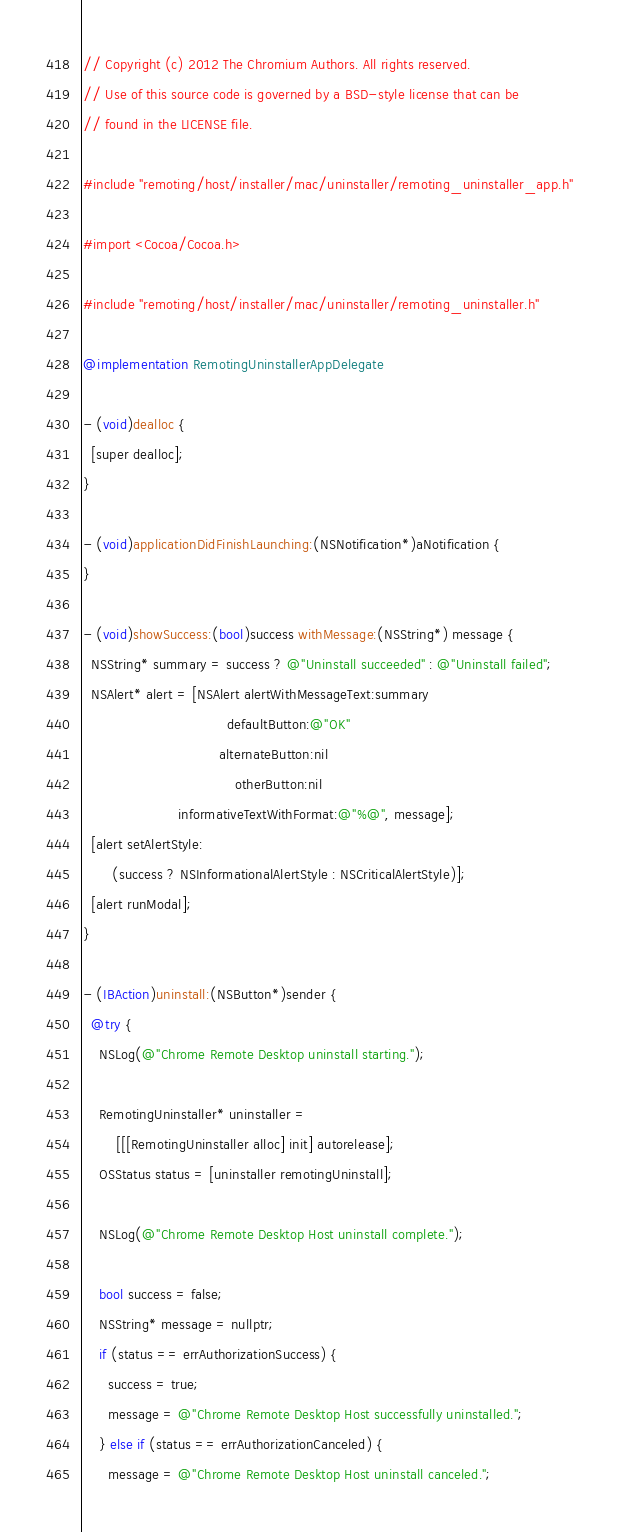<code> <loc_0><loc_0><loc_500><loc_500><_ObjectiveC_>// Copyright (c) 2012 The Chromium Authors. All rights reserved.
// Use of this source code is governed by a BSD-style license that can be
// found in the LICENSE file.

#include "remoting/host/installer/mac/uninstaller/remoting_uninstaller_app.h"

#import <Cocoa/Cocoa.h>

#include "remoting/host/installer/mac/uninstaller/remoting_uninstaller.h"

@implementation RemotingUninstallerAppDelegate

- (void)dealloc {
  [super dealloc];
}

- (void)applicationDidFinishLaunching:(NSNotification*)aNotification {
}

- (void)showSuccess:(bool)success withMessage:(NSString*) message {
  NSString* summary = success ? @"Uninstall succeeded" : @"Uninstall failed";
  NSAlert* alert = [NSAlert alertWithMessageText:summary
                                   defaultButton:@"OK"
                                 alternateButton:nil
                                     otherButton:nil
                       informativeTextWithFormat:@"%@", message];
  [alert setAlertStyle:
       (success ? NSInformationalAlertStyle : NSCriticalAlertStyle)];
  [alert runModal];
}

- (IBAction)uninstall:(NSButton*)sender {
  @try {
    NSLog(@"Chrome Remote Desktop uninstall starting.");

    RemotingUninstaller* uninstaller =
        [[[RemotingUninstaller alloc] init] autorelease];
    OSStatus status = [uninstaller remotingUninstall];

    NSLog(@"Chrome Remote Desktop Host uninstall complete.");

    bool success = false;
    NSString* message = nullptr;
    if (status == errAuthorizationSuccess) {
      success = true;
      message = @"Chrome Remote Desktop Host successfully uninstalled.";
    } else if (status == errAuthorizationCanceled) {
      message = @"Chrome Remote Desktop Host uninstall canceled.";</code> 